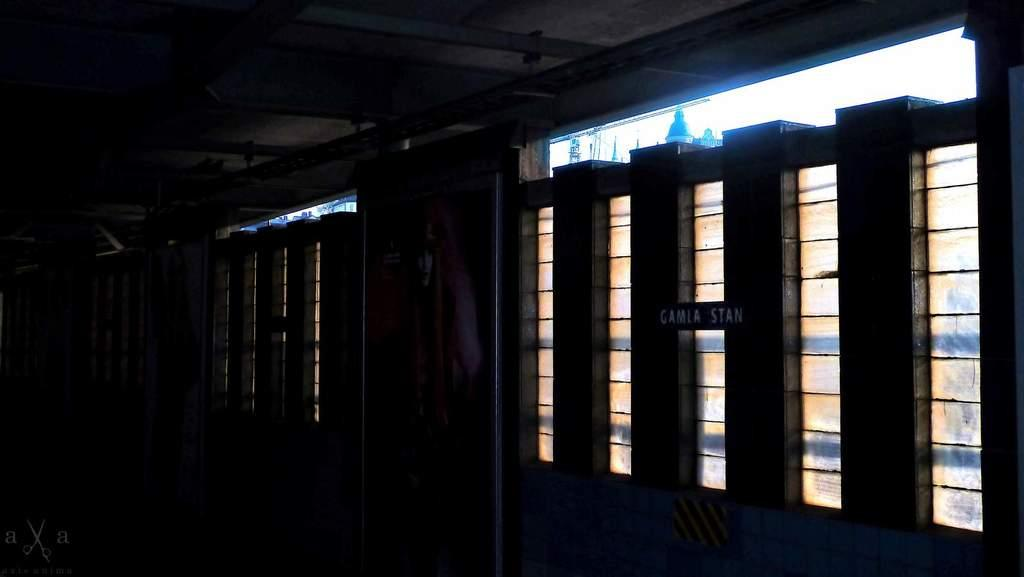Where was the image taken? The image was taken in a room. What can be seen on the right side of the room? There are windows on the right side of the room. How would you describe the lighting in the image? The background of the image is dark. What is visible above the room in the image? There is a ceiling visible in the image. What can be seen outside the windows in the image? Towers and buildings are visible outside the windows. What type of ray is swimming in the image? There is no ray present in the image; it is taken in a room with windows that show towers and buildings outside. Is there a turkey roasting in the room in the image? There is no turkey present in the image; it is focused on the room's interior and the view outside the windows. 